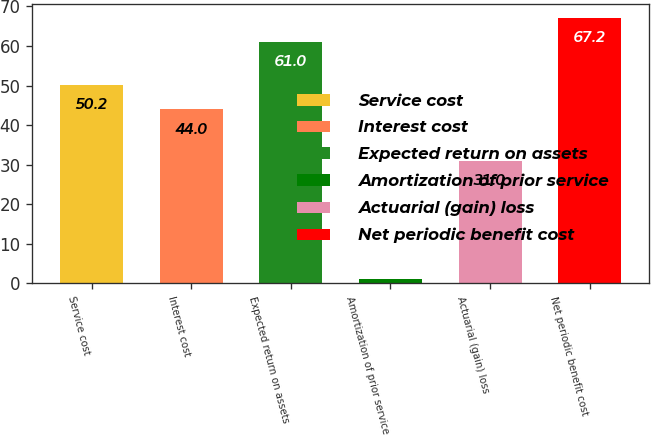<chart> <loc_0><loc_0><loc_500><loc_500><bar_chart><fcel>Service cost<fcel>Interest cost<fcel>Expected return on assets<fcel>Amortization of prior service<fcel>Actuarial (gain) loss<fcel>Net periodic benefit cost<nl><fcel>50.2<fcel>44<fcel>61<fcel>1<fcel>31<fcel>67.2<nl></chart> 